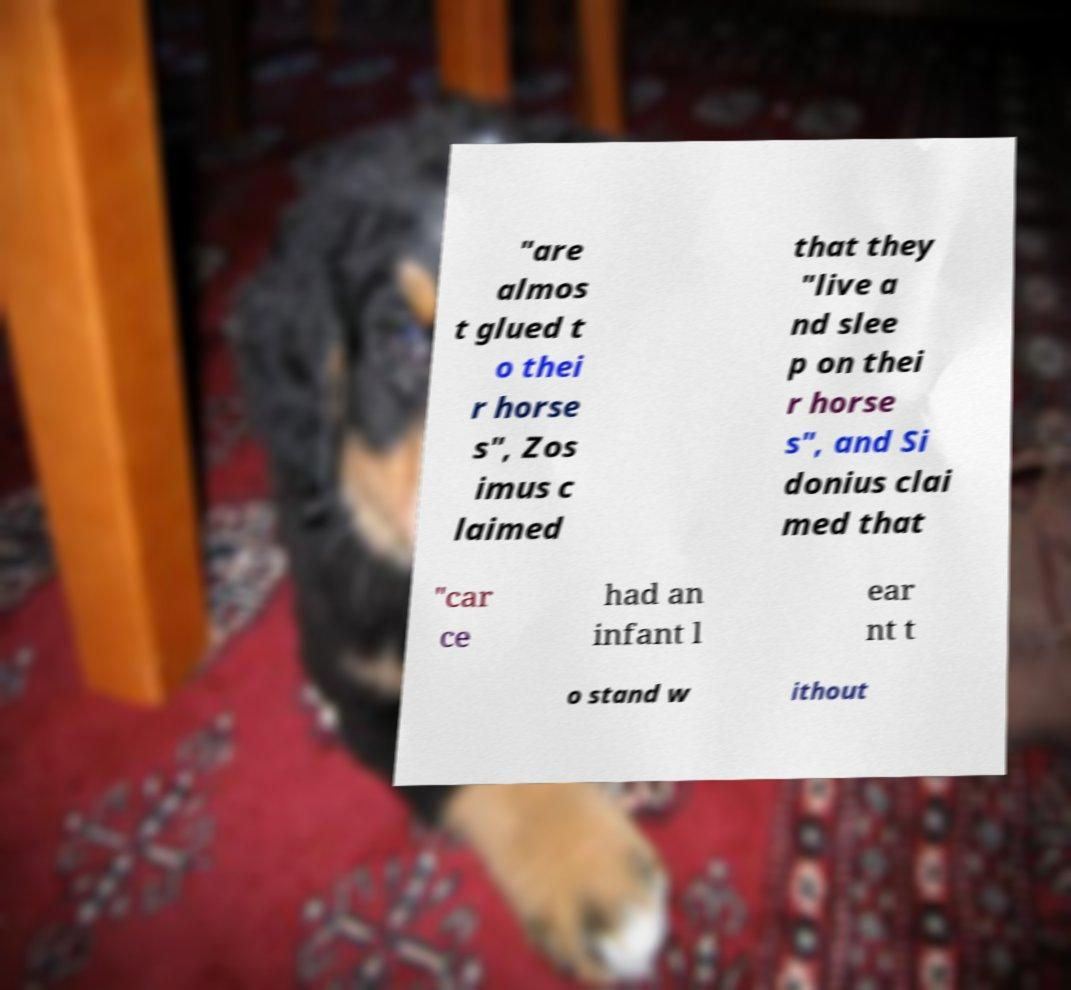Could you extract and type out the text from this image? "are almos t glued t o thei r horse s", Zos imus c laimed that they "live a nd slee p on thei r horse s", and Si donius clai med that "car ce had an infant l ear nt t o stand w ithout 